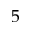<formula> <loc_0><loc_0><loc_500><loc_500>5</formula> 